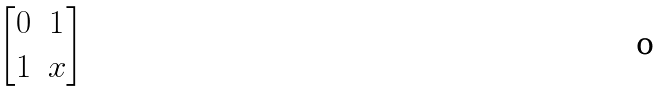<formula> <loc_0><loc_0><loc_500><loc_500>\begin{bmatrix} 0 & 1 \\ 1 & x \end{bmatrix}</formula> 